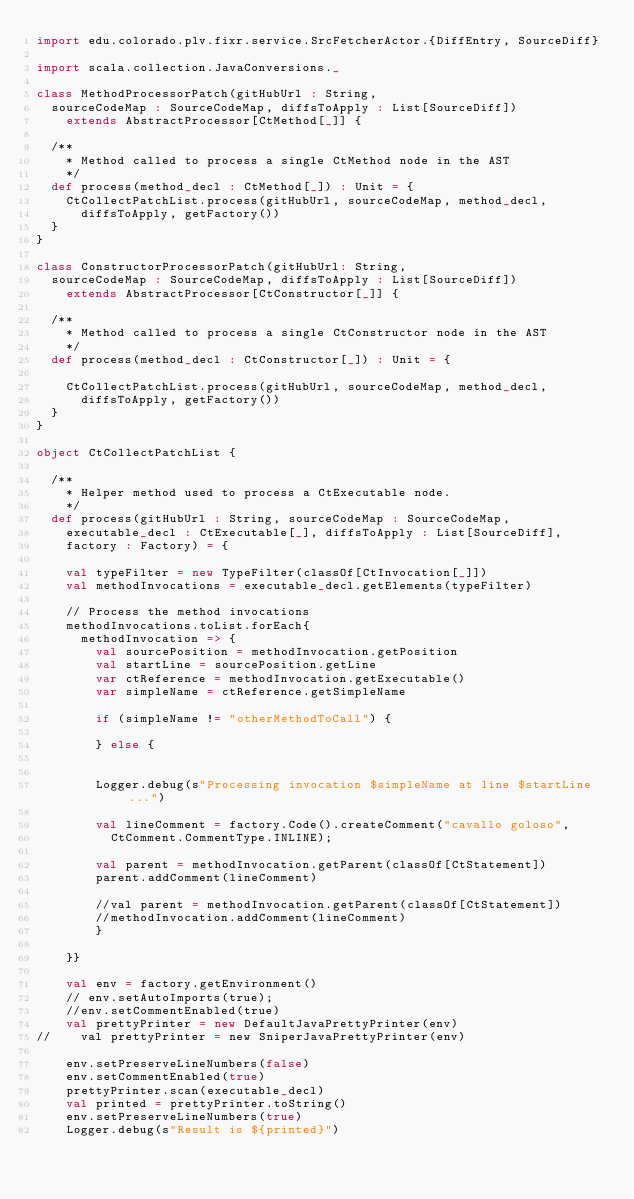<code> <loc_0><loc_0><loc_500><loc_500><_Scala_>import edu.colorado.plv.fixr.service.SrcFetcherActor.{DiffEntry, SourceDiff}

import scala.collection.JavaConversions._

class MethodProcessorPatch(gitHubUrl : String,
  sourceCodeMap : SourceCodeMap, diffsToApply : List[SourceDiff])
    extends AbstractProcessor[CtMethod[_]] {

  /**
    * Method called to process a single CtMethod node in the AST
    */
  def process(method_decl : CtMethod[_]) : Unit = {
    CtCollectPatchList.process(gitHubUrl, sourceCodeMap, method_decl,
      diffsToApply, getFactory())
  }
}

class ConstructorProcessorPatch(gitHubUrl: String,
  sourceCodeMap : SourceCodeMap, diffsToApply : List[SourceDiff])
    extends AbstractProcessor[CtConstructor[_]] {

  /**
    * Method called to process a single CtConstructor node in the AST
    */
  def process(method_decl : CtConstructor[_]) : Unit = {

    CtCollectPatchList.process(gitHubUrl, sourceCodeMap, method_decl,
      diffsToApply, getFactory())
  }
}

object CtCollectPatchList {

  /**
    * Helper method used to process a CtExecutable node.
    */
  def process(gitHubUrl : String, sourceCodeMap : SourceCodeMap,
    executable_decl : CtExecutable[_], diffsToApply : List[SourceDiff],
    factory : Factory) = {

    val typeFilter = new TypeFilter(classOf[CtInvocation[_]])
    val methodInvocations = executable_decl.getElements(typeFilter)

    // Process the method invocations
    methodInvocations.toList.forEach{
      methodInvocation => {
        val sourcePosition = methodInvocation.getPosition
        val startLine = sourcePosition.getLine
        var ctReference = methodInvocation.getExecutable()
        var simpleName = ctReference.getSimpleName

        if (simpleName != "otherMethodToCall") {

        } else {


        Logger.debug(s"Processing invocation $simpleName at line $startLine...")

        val lineComment = factory.Code().createComment("cavallo goloso",
          CtComment.CommentType.INLINE);

        val parent = methodInvocation.getParent(classOf[CtStatement])
        parent.addComment(lineComment)

        //val parent = methodInvocation.getParent(classOf[CtStatement])
        //methodInvocation.addComment(lineComment)
        }

    }}

    val env = factory.getEnvironment()
    // env.setAutoImports(true);
    //env.setCommentEnabled(true)
    val prettyPrinter = new DefaultJavaPrettyPrinter(env)
//    val prettyPrinter = new SniperJavaPrettyPrinter(env)

    env.setPreserveLineNumbers(false)
    env.setCommentEnabled(true)
    prettyPrinter.scan(executable_decl)
    val printed = prettyPrinter.toString()
    env.setPreserveLineNumbers(true)
    Logger.debug(s"Result is ${printed}")


</code> 